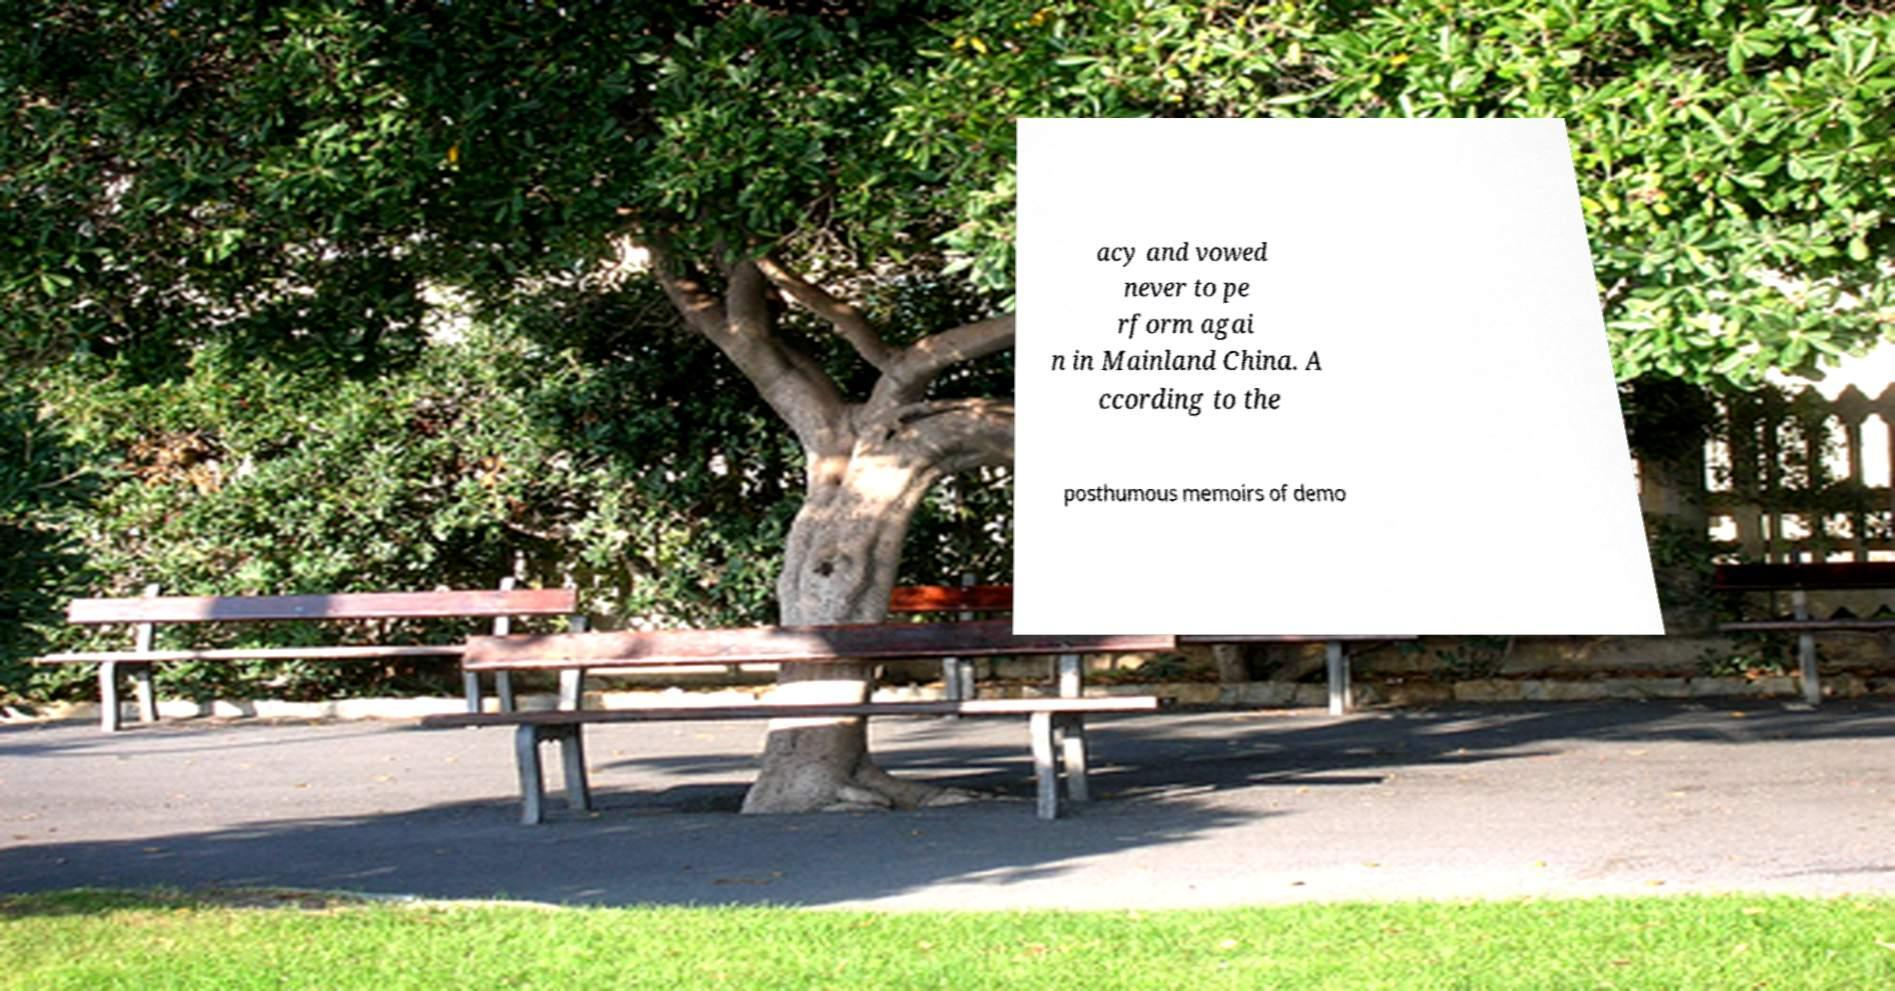Can you read and provide the text displayed in the image?This photo seems to have some interesting text. Can you extract and type it out for me? acy and vowed never to pe rform agai n in Mainland China. A ccording to the posthumous memoirs of demo 